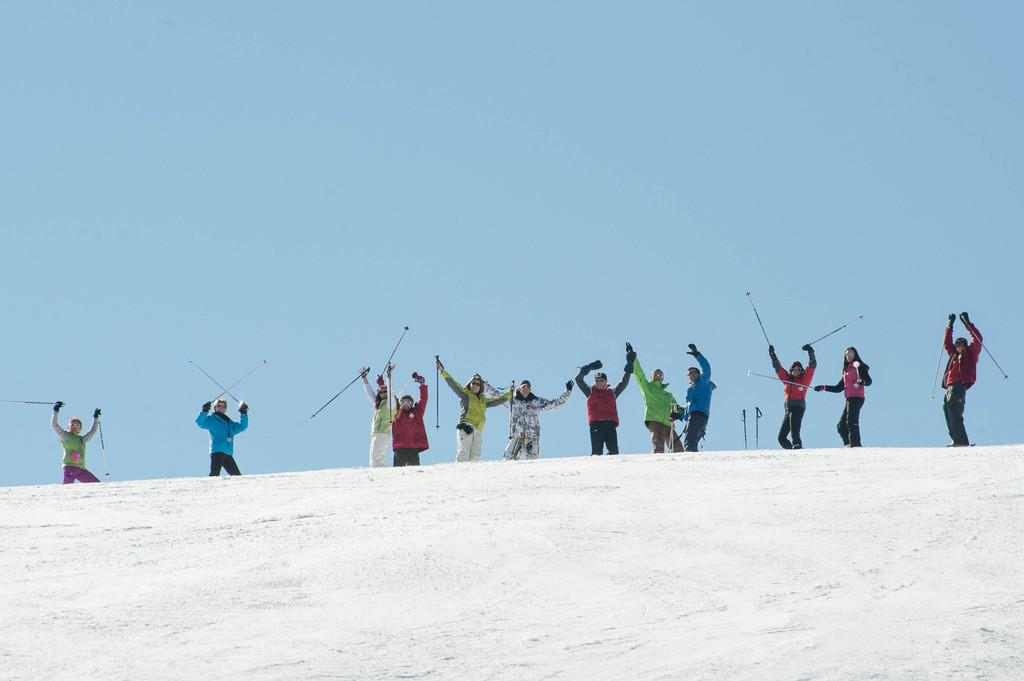How many people are in the image? There is a group of people in the image. What protective gear are the people wearing? The people are wearing helmets, goggles, and gloves. What surface are the people standing on? The people are standing on snow. What are the people holding in their hands? The people are holding sticks in their hands. What can be seen in the background of the image? The sky is visible in the background of the image. How many dimes can be seen scattered on the snow in the image? There are no dimes visible in the image; the people are holding sticks and wearing protective gear. What type of rabbits can be seen hopping around the people in the image? There are no rabbits present in the image; the people are wearing helmets, goggles, and gloves while standing on snow. 